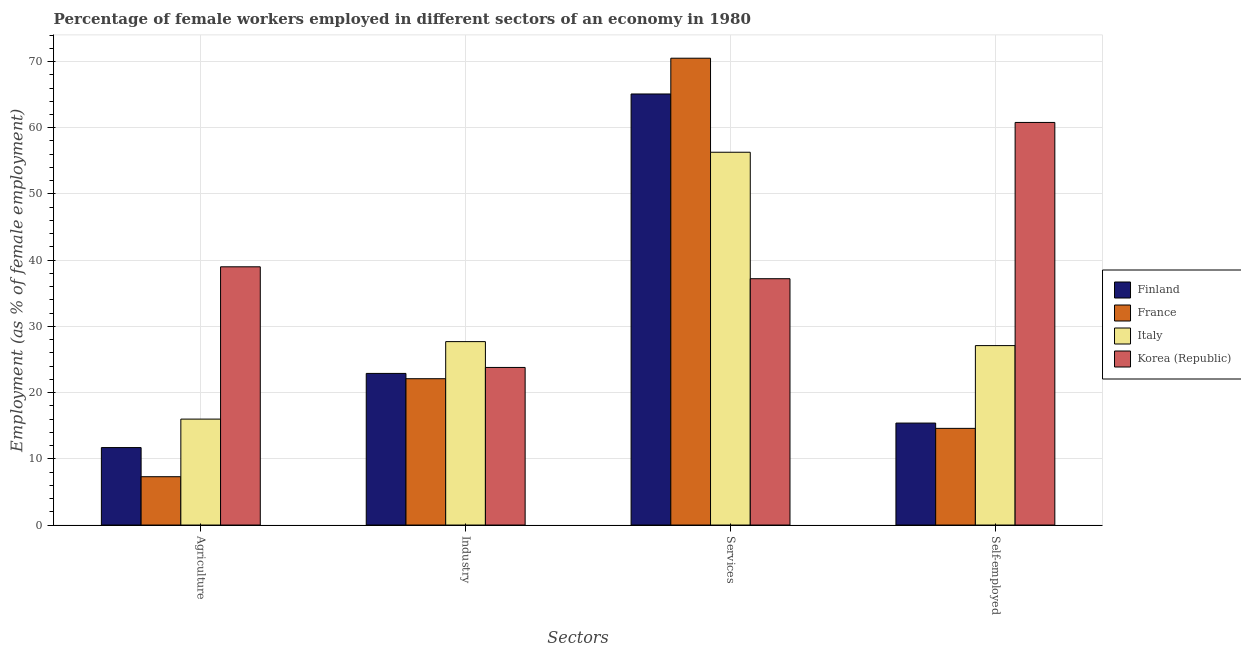Are the number of bars per tick equal to the number of legend labels?
Offer a very short reply. Yes. Are the number of bars on each tick of the X-axis equal?
Your answer should be very brief. Yes. How many bars are there on the 2nd tick from the left?
Keep it short and to the point. 4. What is the label of the 3rd group of bars from the left?
Your answer should be compact. Services. What is the percentage of female workers in industry in Finland?
Provide a succinct answer. 22.9. Across all countries, what is the maximum percentage of self employed female workers?
Give a very brief answer. 60.8. Across all countries, what is the minimum percentage of female workers in industry?
Your answer should be very brief. 22.1. In which country was the percentage of self employed female workers minimum?
Keep it short and to the point. France. What is the total percentage of female workers in services in the graph?
Provide a short and direct response. 229.1. What is the difference between the percentage of female workers in services in France and that in Finland?
Ensure brevity in your answer.  5.4. What is the difference between the percentage of self employed female workers in France and the percentage of female workers in agriculture in Finland?
Your answer should be compact. 2.9. What is the average percentage of female workers in services per country?
Your answer should be very brief. 57.27. What is the difference between the percentage of female workers in agriculture and percentage of female workers in industry in France?
Your response must be concise. -14.8. In how many countries, is the percentage of female workers in agriculture greater than 44 %?
Ensure brevity in your answer.  0. What is the ratio of the percentage of female workers in services in Korea (Republic) to that in Italy?
Offer a very short reply. 0.66. Is the difference between the percentage of self employed female workers in Italy and Finland greater than the difference between the percentage of female workers in services in Italy and Finland?
Keep it short and to the point. Yes. What is the difference between the highest and the lowest percentage of female workers in agriculture?
Give a very brief answer. 31.7. Is it the case that in every country, the sum of the percentage of female workers in industry and percentage of female workers in services is greater than the sum of percentage of self employed female workers and percentage of female workers in agriculture?
Your response must be concise. No. What does the 3rd bar from the left in Agriculture represents?
Ensure brevity in your answer.  Italy. What does the 4th bar from the right in Agriculture represents?
Provide a short and direct response. Finland. Is it the case that in every country, the sum of the percentage of female workers in agriculture and percentage of female workers in industry is greater than the percentage of female workers in services?
Your response must be concise. No. How many bars are there?
Your answer should be very brief. 16. How many countries are there in the graph?
Ensure brevity in your answer.  4. What is the difference between two consecutive major ticks on the Y-axis?
Provide a succinct answer. 10. Does the graph contain any zero values?
Offer a very short reply. No. Does the graph contain grids?
Provide a short and direct response. Yes. Where does the legend appear in the graph?
Ensure brevity in your answer.  Center right. How are the legend labels stacked?
Offer a very short reply. Vertical. What is the title of the graph?
Make the answer very short. Percentage of female workers employed in different sectors of an economy in 1980. What is the label or title of the X-axis?
Keep it short and to the point. Sectors. What is the label or title of the Y-axis?
Offer a terse response. Employment (as % of female employment). What is the Employment (as % of female employment) in Finland in Agriculture?
Your response must be concise. 11.7. What is the Employment (as % of female employment) of France in Agriculture?
Keep it short and to the point. 7.3. What is the Employment (as % of female employment) of Finland in Industry?
Ensure brevity in your answer.  22.9. What is the Employment (as % of female employment) of France in Industry?
Make the answer very short. 22.1. What is the Employment (as % of female employment) of Italy in Industry?
Offer a terse response. 27.7. What is the Employment (as % of female employment) of Korea (Republic) in Industry?
Keep it short and to the point. 23.8. What is the Employment (as % of female employment) in Finland in Services?
Ensure brevity in your answer.  65.1. What is the Employment (as % of female employment) of France in Services?
Your answer should be very brief. 70.5. What is the Employment (as % of female employment) of Italy in Services?
Your answer should be compact. 56.3. What is the Employment (as % of female employment) of Korea (Republic) in Services?
Your answer should be compact. 37.2. What is the Employment (as % of female employment) of Finland in Self-employed?
Provide a short and direct response. 15.4. What is the Employment (as % of female employment) of France in Self-employed?
Make the answer very short. 14.6. What is the Employment (as % of female employment) in Italy in Self-employed?
Make the answer very short. 27.1. What is the Employment (as % of female employment) in Korea (Republic) in Self-employed?
Give a very brief answer. 60.8. Across all Sectors, what is the maximum Employment (as % of female employment) of Finland?
Keep it short and to the point. 65.1. Across all Sectors, what is the maximum Employment (as % of female employment) of France?
Give a very brief answer. 70.5. Across all Sectors, what is the maximum Employment (as % of female employment) in Italy?
Offer a very short reply. 56.3. Across all Sectors, what is the maximum Employment (as % of female employment) of Korea (Republic)?
Your answer should be compact. 60.8. Across all Sectors, what is the minimum Employment (as % of female employment) in Finland?
Ensure brevity in your answer.  11.7. Across all Sectors, what is the minimum Employment (as % of female employment) of France?
Your answer should be compact. 7.3. Across all Sectors, what is the minimum Employment (as % of female employment) in Korea (Republic)?
Provide a succinct answer. 23.8. What is the total Employment (as % of female employment) in Finland in the graph?
Make the answer very short. 115.1. What is the total Employment (as % of female employment) of France in the graph?
Your answer should be very brief. 114.5. What is the total Employment (as % of female employment) of Italy in the graph?
Make the answer very short. 127.1. What is the total Employment (as % of female employment) of Korea (Republic) in the graph?
Make the answer very short. 160.8. What is the difference between the Employment (as % of female employment) of Finland in Agriculture and that in Industry?
Your answer should be very brief. -11.2. What is the difference between the Employment (as % of female employment) in France in Agriculture and that in Industry?
Your response must be concise. -14.8. What is the difference between the Employment (as % of female employment) in Finland in Agriculture and that in Services?
Your answer should be very brief. -53.4. What is the difference between the Employment (as % of female employment) of France in Agriculture and that in Services?
Offer a very short reply. -63.2. What is the difference between the Employment (as % of female employment) of Italy in Agriculture and that in Services?
Give a very brief answer. -40.3. What is the difference between the Employment (as % of female employment) in Korea (Republic) in Agriculture and that in Services?
Give a very brief answer. 1.8. What is the difference between the Employment (as % of female employment) in Finland in Agriculture and that in Self-employed?
Your answer should be very brief. -3.7. What is the difference between the Employment (as % of female employment) of Korea (Republic) in Agriculture and that in Self-employed?
Make the answer very short. -21.8. What is the difference between the Employment (as % of female employment) in Finland in Industry and that in Services?
Make the answer very short. -42.2. What is the difference between the Employment (as % of female employment) in France in Industry and that in Services?
Provide a short and direct response. -48.4. What is the difference between the Employment (as % of female employment) of Italy in Industry and that in Services?
Make the answer very short. -28.6. What is the difference between the Employment (as % of female employment) in Korea (Republic) in Industry and that in Self-employed?
Give a very brief answer. -37. What is the difference between the Employment (as % of female employment) in Finland in Services and that in Self-employed?
Offer a very short reply. 49.7. What is the difference between the Employment (as % of female employment) in France in Services and that in Self-employed?
Your response must be concise. 55.9. What is the difference between the Employment (as % of female employment) of Italy in Services and that in Self-employed?
Provide a short and direct response. 29.2. What is the difference between the Employment (as % of female employment) in Korea (Republic) in Services and that in Self-employed?
Offer a very short reply. -23.6. What is the difference between the Employment (as % of female employment) of Finland in Agriculture and the Employment (as % of female employment) of France in Industry?
Offer a terse response. -10.4. What is the difference between the Employment (as % of female employment) in Finland in Agriculture and the Employment (as % of female employment) in Italy in Industry?
Keep it short and to the point. -16. What is the difference between the Employment (as % of female employment) of Finland in Agriculture and the Employment (as % of female employment) of Korea (Republic) in Industry?
Give a very brief answer. -12.1. What is the difference between the Employment (as % of female employment) in France in Agriculture and the Employment (as % of female employment) in Italy in Industry?
Your answer should be very brief. -20.4. What is the difference between the Employment (as % of female employment) of France in Agriculture and the Employment (as % of female employment) of Korea (Republic) in Industry?
Your answer should be very brief. -16.5. What is the difference between the Employment (as % of female employment) in Finland in Agriculture and the Employment (as % of female employment) in France in Services?
Give a very brief answer. -58.8. What is the difference between the Employment (as % of female employment) of Finland in Agriculture and the Employment (as % of female employment) of Italy in Services?
Provide a short and direct response. -44.6. What is the difference between the Employment (as % of female employment) of Finland in Agriculture and the Employment (as % of female employment) of Korea (Republic) in Services?
Your response must be concise. -25.5. What is the difference between the Employment (as % of female employment) of France in Agriculture and the Employment (as % of female employment) of Italy in Services?
Your answer should be very brief. -49. What is the difference between the Employment (as % of female employment) in France in Agriculture and the Employment (as % of female employment) in Korea (Republic) in Services?
Keep it short and to the point. -29.9. What is the difference between the Employment (as % of female employment) of Italy in Agriculture and the Employment (as % of female employment) of Korea (Republic) in Services?
Keep it short and to the point. -21.2. What is the difference between the Employment (as % of female employment) of Finland in Agriculture and the Employment (as % of female employment) of Italy in Self-employed?
Make the answer very short. -15.4. What is the difference between the Employment (as % of female employment) in Finland in Agriculture and the Employment (as % of female employment) in Korea (Republic) in Self-employed?
Give a very brief answer. -49.1. What is the difference between the Employment (as % of female employment) in France in Agriculture and the Employment (as % of female employment) in Italy in Self-employed?
Ensure brevity in your answer.  -19.8. What is the difference between the Employment (as % of female employment) of France in Agriculture and the Employment (as % of female employment) of Korea (Republic) in Self-employed?
Your response must be concise. -53.5. What is the difference between the Employment (as % of female employment) of Italy in Agriculture and the Employment (as % of female employment) of Korea (Republic) in Self-employed?
Your response must be concise. -44.8. What is the difference between the Employment (as % of female employment) of Finland in Industry and the Employment (as % of female employment) of France in Services?
Provide a succinct answer. -47.6. What is the difference between the Employment (as % of female employment) of Finland in Industry and the Employment (as % of female employment) of Italy in Services?
Your answer should be very brief. -33.4. What is the difference between the Employment (as % of female employment) in Finland in Industry and the Employment (as % of female employment) in Korea (Republic) in Services?
Offer a terse response. -14.3. What is the difference between the Employment (as % of female employment) in France in Industry and the Employment (as % of female employment) in Italy in Services?
Your response must be concise. -34.2. What is the difference between the Employment (as % of female employment) of France in Industry and the Employment (as % of female employment) of Korea (Republic) in Services?
Provide a succinct answer. -15.1. What is the difference between the Employment (as % of female employment) in Italy in Industry and the Employment (as % of female employment) in Korea (Republic) in Services?
Offer a very short reply. -9.5. What is the difference between the Employment (as % of female employment) in Finland in Industry and the Employment (as % of female employment) in Korea (Republic) in Self-employed?
Provide a succinct answer. -37.9. What is the difference between the Employment (as % of female employment) of France in Industry and the Employment (as % of female employment) of Korea (Republic) in Self-employed?
Give a very brief answer. -38.7. What is the difference between the Employment (as % of female employment) in Italy in Industry and the Employment (as % of female employment) in Korea (Republic) in Self-employed?
Provide a short and direct response. -33.1. What is the difference between the Employment (as % of female employment) of Finland in Services and the Employment (as % of female employment) of France in Self-employed?
Make the answer very short. 50.5. What is the difference between the Employment (as % of female employment) of Finland in Services and the Employment (as % of female employment) of Italy in Self-employed?
Make the answer very short. 38. What is the difference between the Employment (as % of female employment) of France in Services and the Employment (as % of female employment) of Italy in Self-employed?
Provide a succinct answer. 43.4. What is the difference between the Employment (as % of female employment) of Italy in Services and the Employment (as % of female employment) of Korea (Republic) in Self-employed?
Provide a short and direct response. -4.5. What is the average Employment (as % of female employment) in Finland per Sectors?
Ensure brevity in your answer.  28.77. What is the average Employment (as % of female employment) of France per Sectors?
Your answer should be very brief. 28.62. What is the average Employment (as % of female employment) in Italy per Sectors?
Offer a terse response. 31.77. What is the average Employment (as % of female employment) in Korea (Republic) per Sectors?
Offer a very short reply. 40.2. What is the difference between the Employment (as % of female employment) in Finland and Employment (as % of female employment) in France in Agriculture?
Offer a terse response. 4.4. What is the difference between the Employment (as % of female employment) of Finland and Employment (as % of female employment) of Korea (Republic) in Agriculture?
Keep it short and to the point. -27.3. What is the difference between the Employment (as % of female employment) in France and Employment (as % of female employment) in Italy in Agriculture?
Your answer should be very brief. -8.7. What is the difference between the Employment (as % of female employment) of France and Employment (as % of female employment) of Korea (Republic) in Agriculture?
Provide a short and direct response. -31.7. What is the difference between the Employment (as % of female employment) in Finland and Employment (as % of female employment) in France in Industry?
Ensure brevity in your answer.  0.8. What is the difference between the Employment (as % of female employment) in Finland and Employment (as % of female employment) in Italy in Industry?
Provide a short and direct response. -4.8. What is the difference between the Employment (as % of female employment) in France and Employment (as % of female employment) in Italy in Industry?
Your response must be concise. -5.6. What is the difference between the Employment (as % of female employment) of France and Employment (as % of female employment) of Korea (Republic) in Industry?
Offer a very short reply. -1.7. What is the difference between the Employment (as % of female employment) of Italy and Employment (as % of female employment) of Korea (Republic) in Industry?
Your answer should be very brief. 3.9. What is the difference between the Employment (as % of female employment) in Finland and Employment (as % of female employment) in France in Services?
Give a very brief answer. -5.4. What is the difference between the Employment (as % of female employment) in Finland and Employment (as % of female employment) in Korea (Republic) in Services?
Provide a short and direct response. 27.9. What is the difference between the Employment (as % of female employment) of France and Employment (as % of female employment) of Korea (Republic) in Services?
Keep it short and to the point. 33.3. What is the difference between the Employment (as % of female employment) of Italy and Employment (as % of female employment) of Korea (Republic) in Services?
Keep it short and to the point. 19.1. What is the difference between the Employment (as % of female employment) in Finland and Employment (as % of female employment) in Italy in Self-employed?
Your answer should be compact. -11.7. What is the difference between the Employment (as % of female employment) of Finland and Employment (as % of female employment) of Korea (Republic) in Self-employed?
Give a very brief answer. -45.4. What is the difference between the Employment (as % of female employment) in France and Employment (as % of female employment) in Italy in Self-employed?
Offer a very short reply. -12.5. What is the difference between the Employment (as % of female employment) of France and Employment (as % of female employment) of Korea (Republic) in Self-employed?
Your response must be concise. -46.2. What is the difference between the Employment (as % of female employment) in Italy and Employment (as % of female employment) in Korea (Republic) in Self-employed?
Give a very brief answer. -33.7. What is the ratio of the Employment (as % of female employment) in Finland in Agriculture to that in Industry?
Give a very brief answer. 0.51. What is the ratio of the Employment (as % of female employment) in France in Agriculture to that in Industry?
Provide a short and direct response. 0.33. What is the ratio of the Employment (as % of female employment) in Italy in Agriculture to that in Industry?
Keep it short and to the point. 0.58. What is the ratio of the Employment (as % of female employment) in Korea (Republic) in Agriculture to that in Industry?
Your answer should be very brief. 1.64. What is the ratio of the Employment (as % of female employment) of Finland in Agriculture to that in Services?
Your answer should be very brief. 0.18. What is the ratio of the Employment (as % of female employment) of France in Agriculture to that in Services?
Your answer should be very brief. 0.1. What is the ratio of the Employment (as % of female employment) of Italy in Agriculture to that in Services?
Keep it short and to the point. 0.28. What is the ratio of the Employment (as % of female employment) in Korea (Republic) in Agriculture to that in Services?
Provide a succinct answer. 1.05. What is the ratio of the Employment (as % of female employment) of Finland in Agriculture to that in Self-employed?
Keep it short and to the point. 0.76. What is the ratio of the Employment (as % of female employment) in Italy in Agriculture to that in Self-employed?
Make the answer very short. 0.59. What is the ratio of the Employment (as % of female employment) in Korea (Republic) in Agriculture to that in Self-employed?
Ensure brevity in your answer.  0.64. What is the ratio of the Employment (as % of female employment) in Finland in Industry to that in Services?
Offer a terse response. 0.35. What is the ratio of the Employment (as % of female employment) of France in Industry to that in Services?
Keep it short and to the point. 0.31. What is the ratio of the Employment (as % of female employment) in Italy in Industry to that in Services?
Provide a succinct answer. 0.49. What is the ratio of the Employment (as % of female employment) of Korea (Republic) in Industry to that in Services?
Provide a short and direct response. 0.64. What is the ratio of the Employment (as % of female employment) in Finland in Industry to that in Self-employed?
Your answer should be compact. 1.49. What is the ratio of the Employment (as % of female employment) of France in Industry to that in Self-employed?
Your response must be concise. 1.51. What is the ratio of the Employment (as % of female employment) of Italy in Industry to that in Self-employed?
Provide a succinct answer. 1.02. What is the ratio of the Employment (as % of female employment) of Korea (Republic) in Industry to that in Self-employed?
Give a very brief answer. 0.39. What is the ratio of the Employment (as % of female employment) in Finland in Services to that in Self-employed?
Provide a succinct answer. 4.23. What is the ratio of the Employment (as % of female employment) in France in Services to that in Self-employed?
Your response must be concise. 4.83. What is the ratio of the Employment (as % of female employment) in Italy in Services to that in Self-employed?
Your answer should be compact. 2.08. What is the ratio of the Employment (as % of female employment) in Korea (Republic) in Services to that in Self-employed?
Your response must be concise. 0.61. What is the difference between the highest and the second highest Employment (as % of female employment) of Finland?
Offer a very short reply. 42.2. What is the difference between the highest and the second highest Employment (as % of female employment) of France?
Your answer should be very brief. 48.4. What is the difference between the highest and the second highest Employment (as % of female employment) of Italy?
Provide a short and direct response. 28.6. What is the difference between the highest and the second highest Employment (as % of female employment) of Korea (Republic)?
Provide a succinct answer. 21.8. What is the difference between the highest and the lowest Employment (as % of female employment) in Finland?
Keep it short and to the point. 53.4. What is the difference between the highest and the lowest Employment (as % of female employment) of France?
Give a very brief answer. 63.2. What is the difference between the highest and the lowest Employment (as % of female employment) of Italy?
Offer a terse response. 40.3. What is the difference between the highest and the lowest Employment (as % of female employment) of Korea (Republic)?
Your response must be concise. 37. 